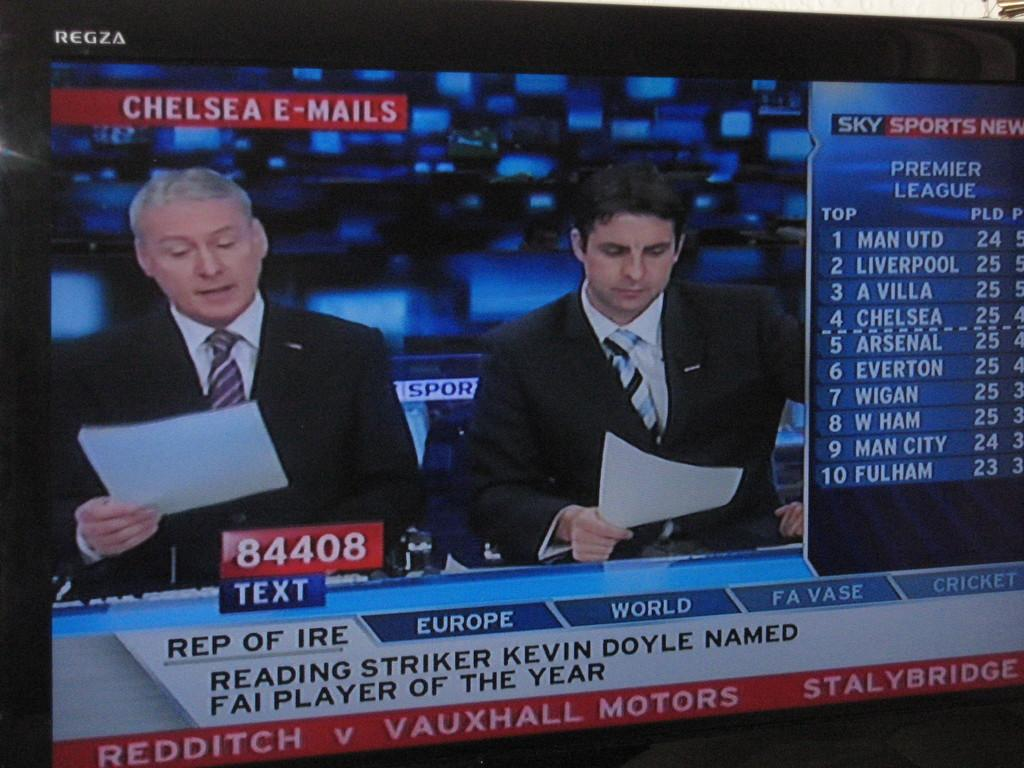<image>
Render a clear and concise summary of the photo. some people reading the news with the number 84408 on the screen 